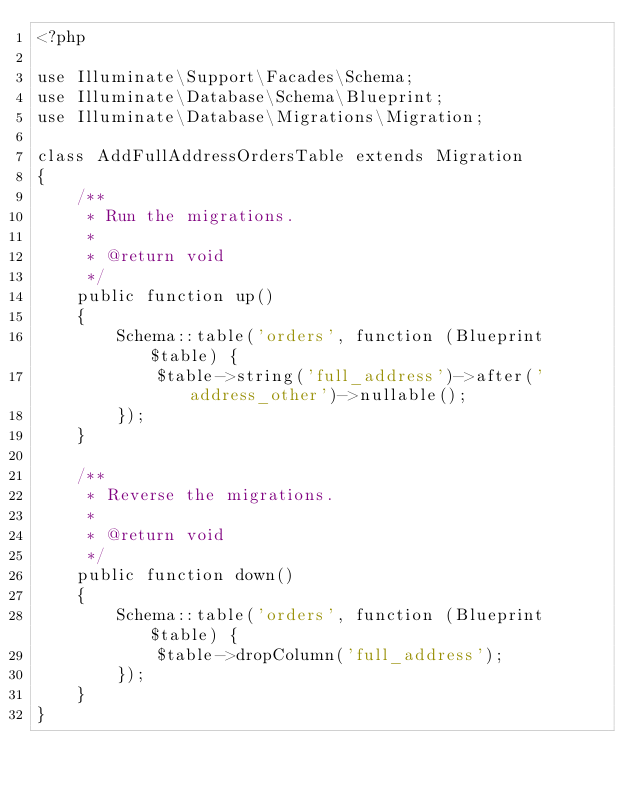Convert code to text. <code><loc_0><loc_0><loc_500><loc_500><_PHP_><?php

use Illuminate\Support\Facades\Schema;
use Illuminate\Database\Schema\Blueprint;
use Illuminate\Database\Migrations\Migration;

class AddFullAddressOrdersTable extends Migration
{
    /**
     * Run the migrations.
     *
     * @return void
     */
    public function up()
    {
        Schema::table('orders', function (Blueprint $table) {
            $table->string('full_address')->after('address_other')->nullable();
        });
    }

    /**
     * Reverse the migrations.
     *
     * @return void
     */
    public function down()
    {
        Schema::table('orders', function (Blueprint $table) {
            $table->dropColumn('full_address');
        });
    }
}
</code> 